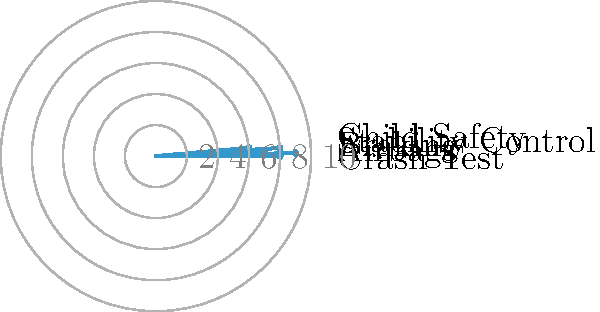The radar chart above shows the safety ratings of a popular compact SUV model on a scale of 0 to 10. Which safety feature has the highest rating, and what is the sum of the two lowest-rated features? To answer this question, we need to analyze the radar chart and follow these steps:

1. Identify the highest-rated safety feature:
   - Examine each axis of the radar chart
   - The axis that extends furthest from the center represents the highest rating
   - In this case, "Airbags" has the highest rating of 9

2. Identify the two lowest-rated safety features:
   - Look for the two axes that extend the least from the center
   - "Child Safety" has the lowest rating of 6
   - "Braking" has the second-lowest rating of 7

3. Calculate the sum of the two lowest-rated features:
   - Child Safety (6) + Braking (7) = 13

Therefore, the highest-rated safety feature is Airbags, and the sum of the two lowest-rated features is 13.
Answer: Airbags; 13 